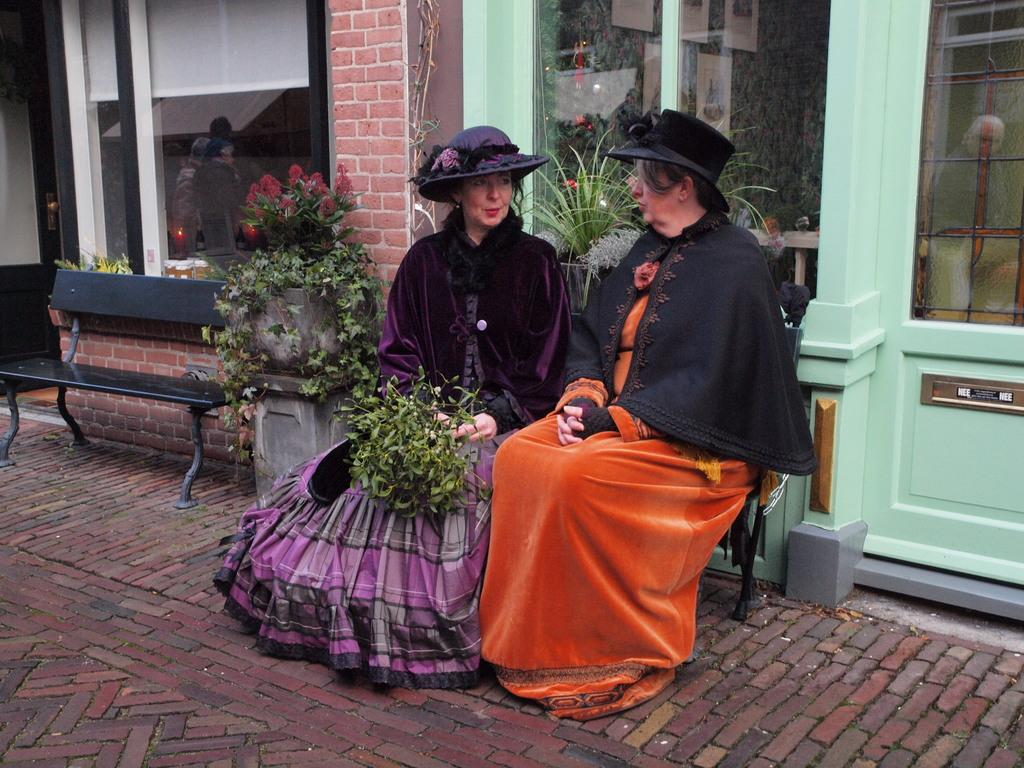How many people are in the image? There are two ladies in the image. What are the ladies doing in the image? The ladies are sitting on chairs. What is one of the ladies holding? One of the ladies is holding a bunch of leaves. What can be seen in the background of the image? There is a flower pot in the background of the image. What type of linen is draped over the chairs in the image? There is no linen draped over the chairs in the image. What liquid is being poured from the flower pot in the image? There is no liquid being poured from the flower pot in the image; it is a stationary object. 